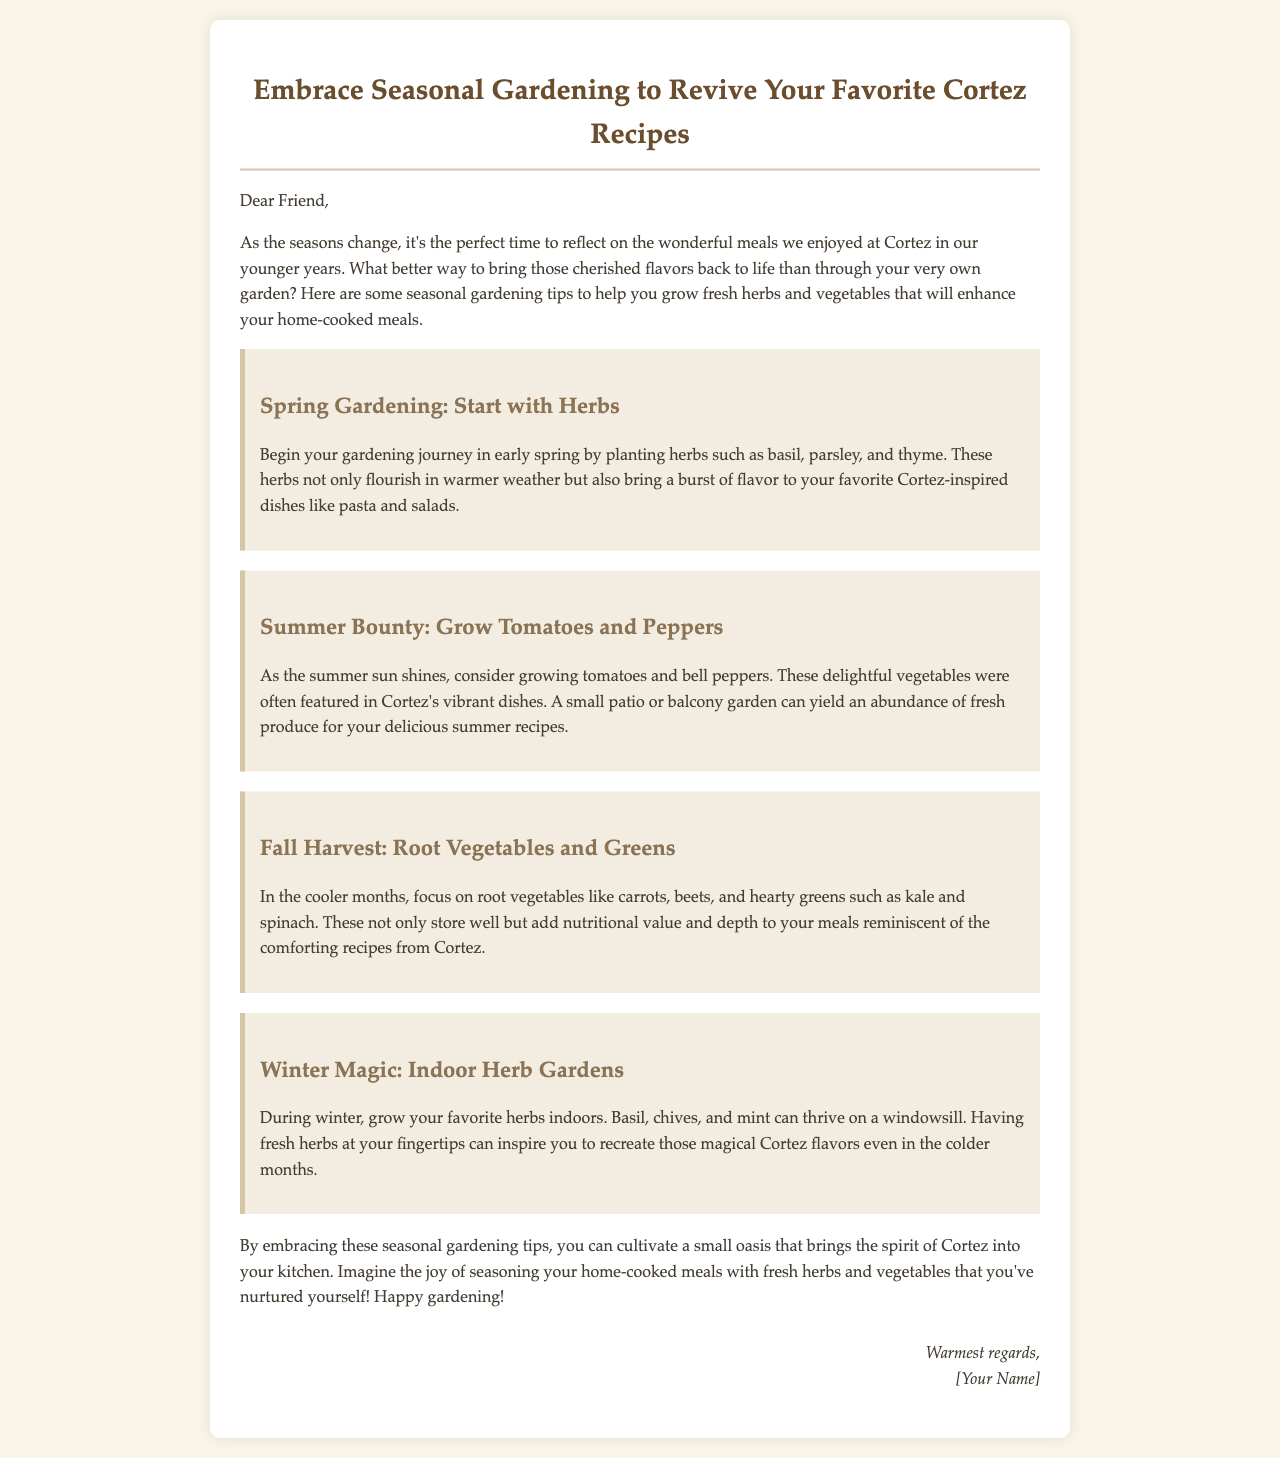What herbs should you start with in spring? The document mentions starting with herbs such as basil, parsley, and thyme in spring.
Answer: basil, parsley, thyme What vegetables are suggested for summer gardening? The document suggests growing tomatoes and bell peppers during the summer.
Answer: tomatoes, bell peppers Which root vegetables are recommended for the fall? It mentions carrots and beets as root vegetables for the fall season.
Answer: carrots, beets What is a recommended indoor herb to grow in winter? The document recommends growing basil, chives, or mint indoors during winter.
Answer: basil, chives, mint What kind of gardening is discussed throughout the email? The email focuses on seasonal gardening tips for herbs and vegetables.
Answer: seasonal gardening How does the email suggest enhancing home-cooked meals? It suggests using fresh herbs and vegetables grown at home to enhance meals.
Answer: fresh herbs and vegetables What season is best for growing hearty greens like kale? The document states that fall is the best season for growing hearty greens.
Answer: fall What is the purpose of the email? The purpose is to provide seasonal gardening tips to revive favorite recipes.
Answer: to provide seasonal gardening tips 